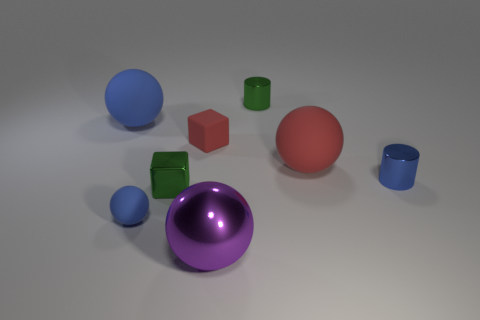Subtract all big purple shiny balls. How many balls are left? 3 Add 1 big red balls. How many objects exist? 9 Subtract all red balls. How many balls are left? 3 Subtract 1 cubes. How many cubes are left? 1 Subtract all cylinders. How many objects are left? 6 Add 1 small green metallic cylinders. How many small green metallic cylinders are left? 2 Add 6 cyan matte cylinders. How many cyan matte cylinders exist? 6 Subtract 1 green cylinders. How many objects are left? 7 Subtract all green cubes. Subtract all brown cylinders. How many cubes are left? 1 Subtract all green cubes. How many green cylinders are left? 1 